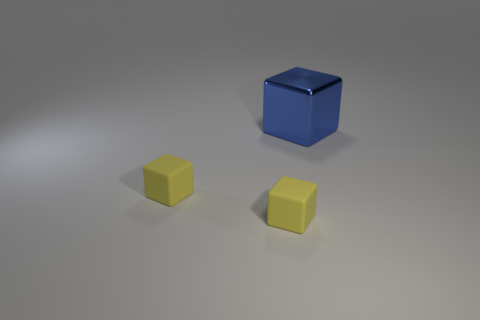Is there any other thing that has the same size as the shiny thing?
Ensure brevity in your answer.  No. Is the number of cubes to the right of the large cube less than the number of large cyan things?
Provide a succinct answer. No. How many objects are either cubes that are on the left side of the blue metal thing or blocks left of the blue block?
Offer a very short reply. 2. How many small yellow rubber things are the same shape as the big blue metal thing?
Offer a terse response. 2. How many objects are either big brown matte blocks or small cubes?
Give a very brief answer. 2. What number of cubes are metallic objects or small matte things?
Provide a short and direct response. 3. How many other objects are there of the same size as the blue object?
Provide a succinct answer. 0. Are there the same number of metal cubes that are right of the blue thing and tiny purple metal spheres?
Your answer should be very brief. Yes. The shiny object has what color?
Provide a succinct answer. Blue. How many other things are there of the same shape as the blue metallic thing?
Ensure brevity in your answer.  2. 